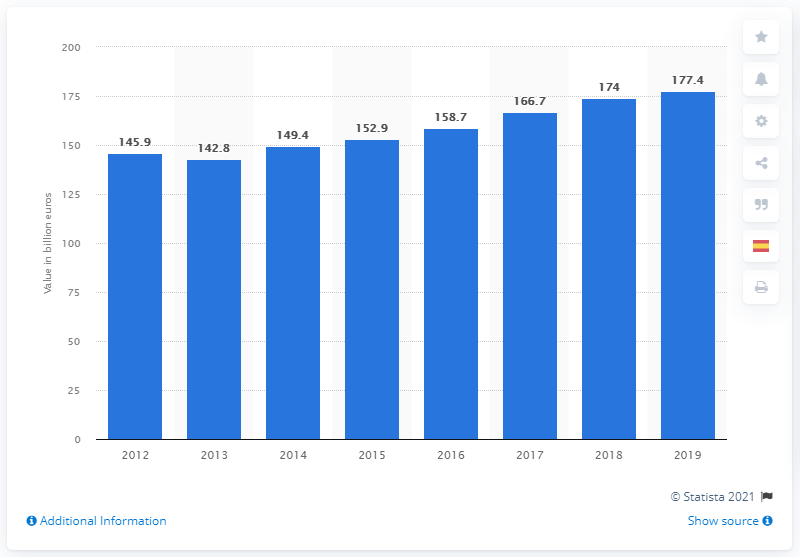What was Spain's GDP contribution in 2019?
 177.4 